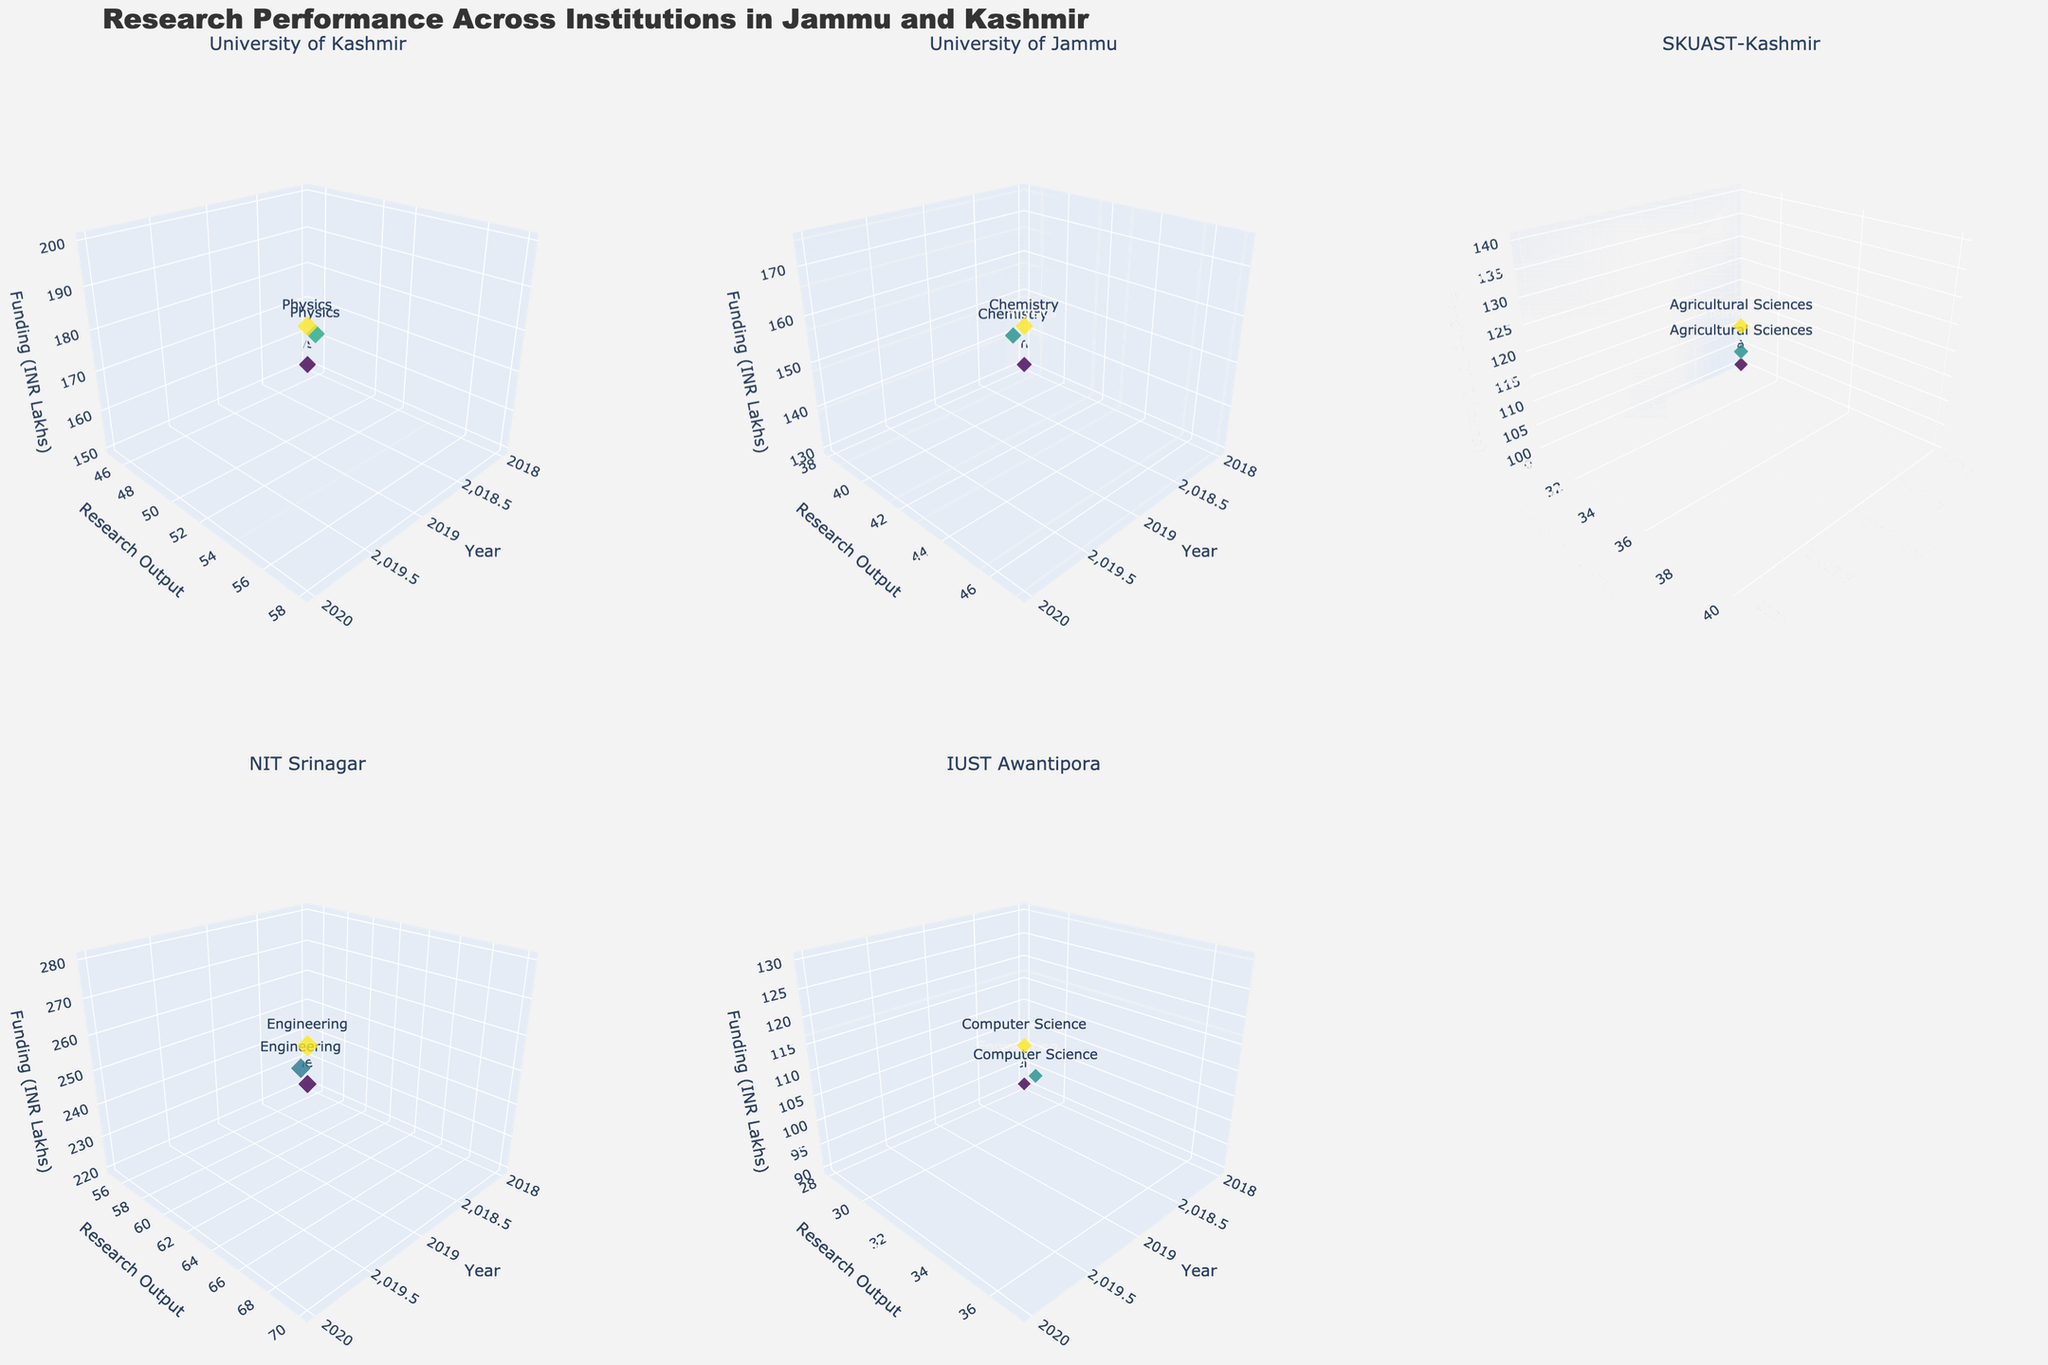Which institution has the highest research output for the year 2020? From the figures, NIT Srinagar's research output in 2020 is the highest compared to other institutions. Its data point for 2020 is farther along the y-axis (Research Output) than any other institution's data point for the same year.
Answer: NIT Srinagar What is the trend of funding in INR Lakhs for IUST Awantipora from 2018 to 2020? The funding for IUST Awantipora increases each year from 2018 to 2020. In 2018, the funding is at 90 INR Lakhs, it increases to 110 INR Lakhs in 2019, and further increases to 130 INR Lakhs in 2020.
Answer: Increasing Which discipline at University of Kashmir had the greatest increase in research output from 2019 to 2020? For University of Kashmir, we note their Physics discipline data points. Research Output increased from 52 to 58 between these years, showing a 6-point increase. This is the greatest rise when compared year-on-year for their disciplines.
Answer: Physics How does the impact factor of Agricultural Sciences at SKUAST-Kashmir in 2019 compare to that in 2020? By comparing the sizes of the markers (which represent the impact factor) for Agricultural Sciences at SKUAST-Kashmir in 2019 and 2020, it is observed that the marker size is moderately larger in 2020 than in 2019, indicating an increase in the impact factor from 2.4 to 2.6.
Answer: Higher in 2020 What is the funding difference between University of Jammu's Chemistry discipline and NIT Srinagar's Engineering discipline in 2019? Funding for University of Jammu's Chemistry in 2019 is 155 INR Lakhs, and for NIT Srinagar's Engineering, it is 250 INR Lakhs. The difference is calculated as 250 - 155 = 95 INR Lakhs.
Answer: 95 INR Lakhs Which institution saw the greatest change in impact factor from 2018 to 2020? Observing the change in marker sizes (impact factor) over time, NIT Srinagar's Engineering discipline stands out. It increased from an impact factor of 3.0 in 2018 to 3.5 in 2020, marking a change of 0.5, which is the largest among all institutions.
Answer: NIT Srinagar In which year did the University of Jammu's Chemistry discipline receive the highest funding? Referring to University of Jammu's Chemistry data points, the 2020 marker position on the z-axis (representing funding) is at 175 INR Lakhs which is higher than other years.
Answer: 2020 